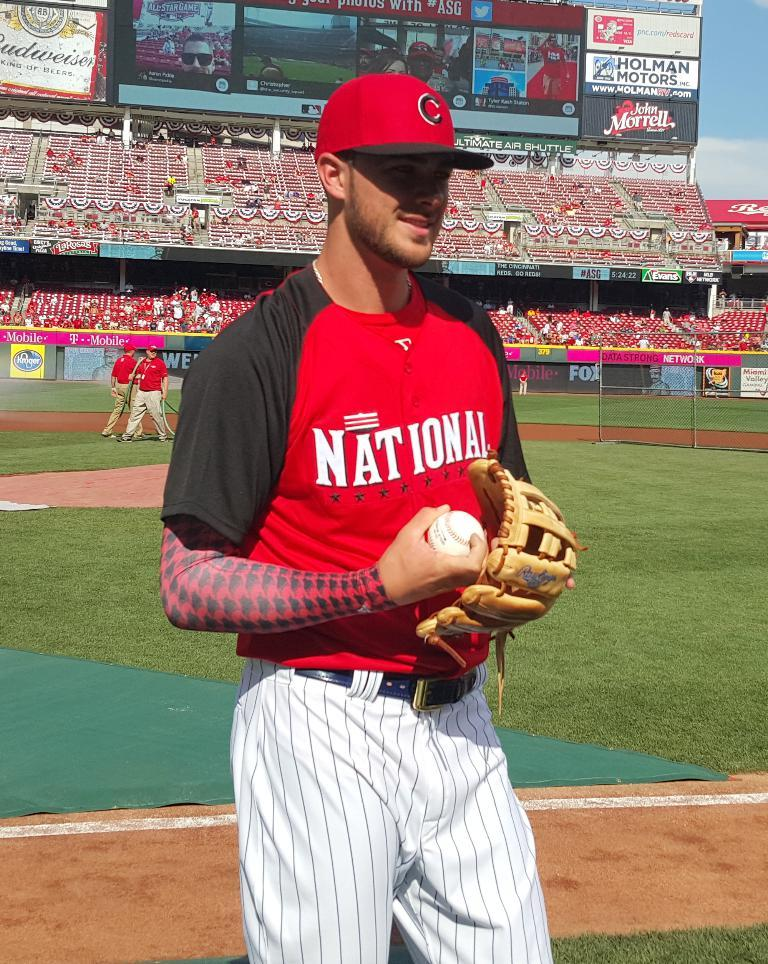<image>
Describe the image concisely. A man in a National baseball uniform stands with a glove and ball 